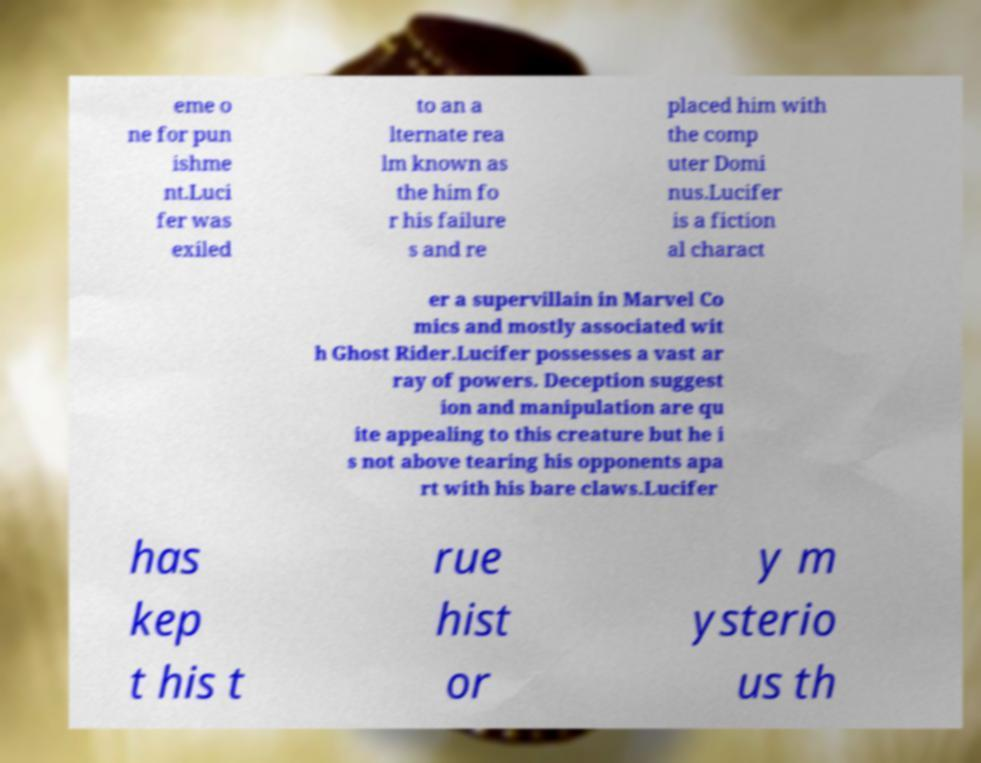Please identify and transcribe the text found in this image. eme o ne for pun ishme nt.Luci fer was exiled to an a lternate rea lm known as the him fo r his failure s and re placed him with the comp uter Domi nus.Lucifer is a fiction al charact er a supervillain in Marvel Co mics and mostly associated wit h Ghost Rider.Lucifer possesses a vast ar ray of powers. Deception suggest ion and manipulation are qu ite appealing to this creature but he i s not above tearing his opponents apa rt with his bare claws.Lucifer has kep t his t rue hist or y m ysterio us th 